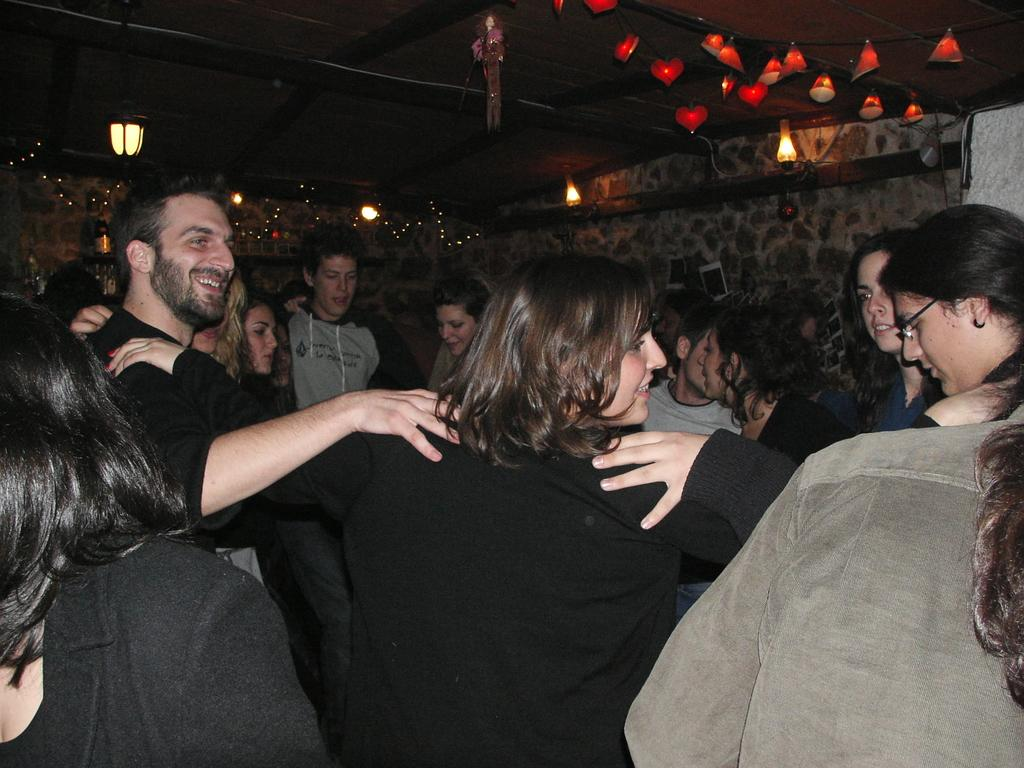How many people are in the image? There is a group of people in the image, but the exact number is not specified. Where are the people located in the image? The people are on a path in the image. What is behind the people in the image? There is a wall behind the people in the image. What can be seen at the top of the wall? Decorative lights are present at the top of the wall. What type of plastic is used to make the sky in the image? The sky in the image is not made of plastic; it is a natural part of the environment. 